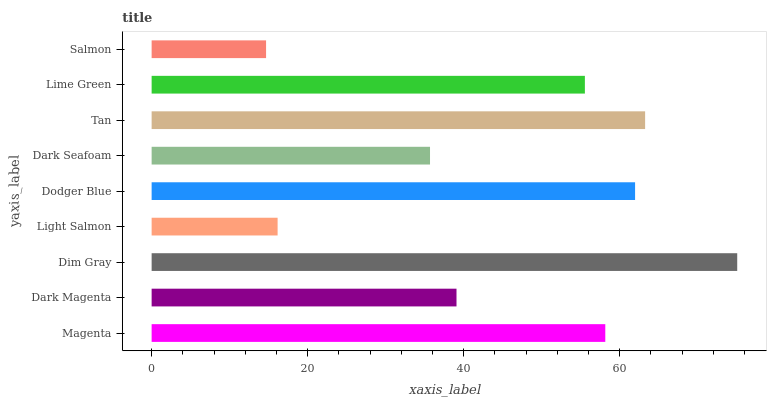Is Salmon the minimum?
Answer yes or no. Yes. Is Dim Gray the maximum?
Answer yes or no. Yes. Is Dark Magenta the minimum?
Answer yes or no. No. Is Dark Magenta the maximum?
Answer yes or no. No. Is Magenta greater than Dark Magenta?
Answer yes or no. Yes. Is Dark Magenta less than Magenta?
Answer yes or no. Yes. Is Dark Magenta greater than Magenta?
Answer yes or no. No. Is Magenta less than Dark Magenta?
Answer yes or no. No. Is Lime Green the high median?
Answer yes or no. Yes. Is Lime Green the low median?
Answer yes or no. Yes. Is Dim Gray the high median?
Answer yes or no. No. Is Dodger Blue the low median?
Answer yes or no. No. 